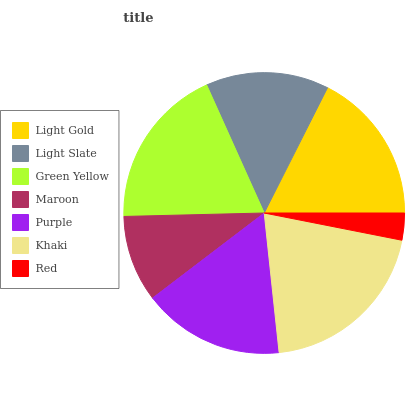Is Red the minimum?
Answer yes or no. Yes. Is Khaki the maximum?
Answer yes or no. Yes. Is Light Slate the minimum?
Answer yes or no. No. Is Light Slate the maximum?
Answer yes or no. No. Is Light Gold greater than Light Slate?
Answer yes or no. Yes. Is Light Slate less than Light Gold?
Answer yes or no. Yes. Is Light Slate greater than Light Gold?
Answer yes or no. No. Is Light Gold less than Light Slate?
Answer yes or no. No. Is Purple the high median?
Answer yes or no. Yes. Is Purple the low median?
Answer yes or no. Yes. Is Light Gold the high median?
Answer yes or no. No. Is Light Slate the low median?
Answer yes or no. No. 